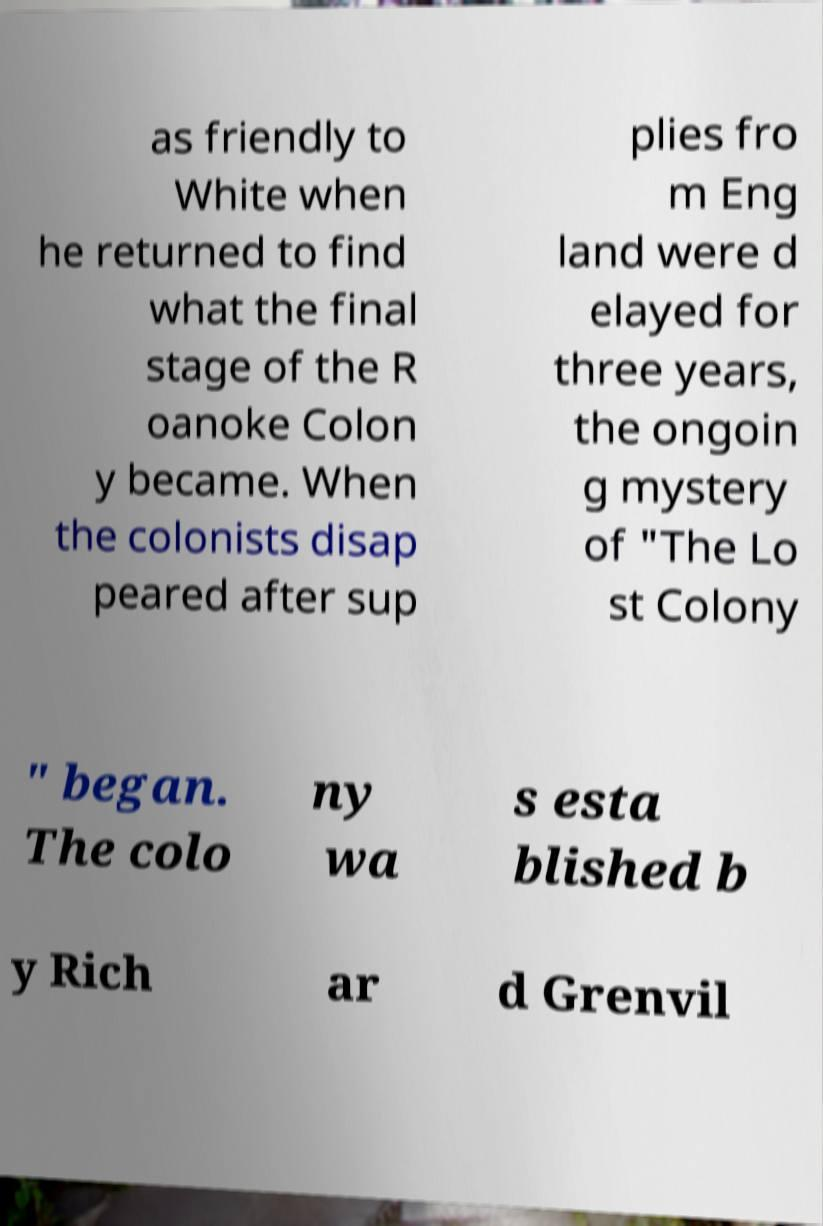There's text embedded in this image that I need extracted. Can you transcribe it verbatim? as friendly to White when he returned to find what the final stage of the R oanoke Colon y became. When the colonists disap peared after sup plies fro m Eng land were d elayed for three years, the ongoin g mystery of "The Lo st Colony " began. The colo ny wa s esta blished b y Rich ar d Grenvil 